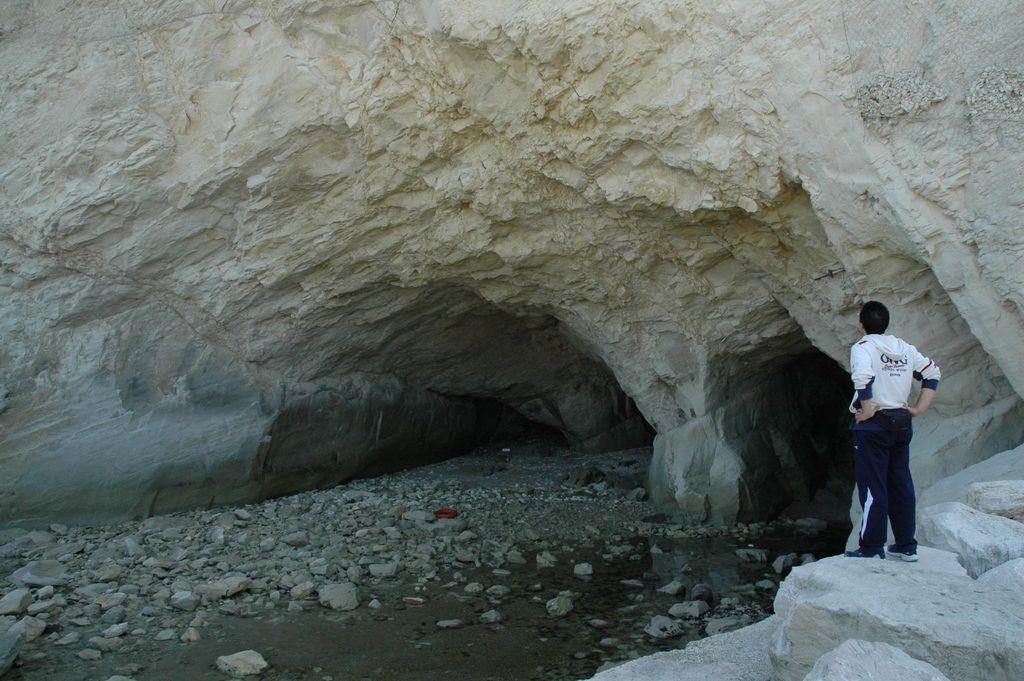Could you give a brief overview of what you see in this image? In the picture we can see a person wearing white color shirt, blue color pant standing on the stone surface and we can see a rock and there is cave and there are some stones which are on ground. 